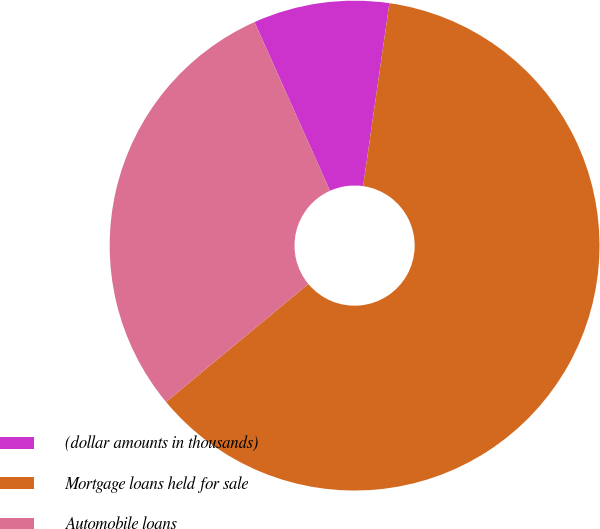Convert chart to OTSL. <chart><loc_0><loc_0><loc_500><loc_500><pie_chart><fcel>(dollar amounts in thousands)<fcel>Mortgage loans held for sale<fcel>Automobile loans<nl><fcel>8.97%<fcel>61.71%<fcel>29.32%<nl></chart> 